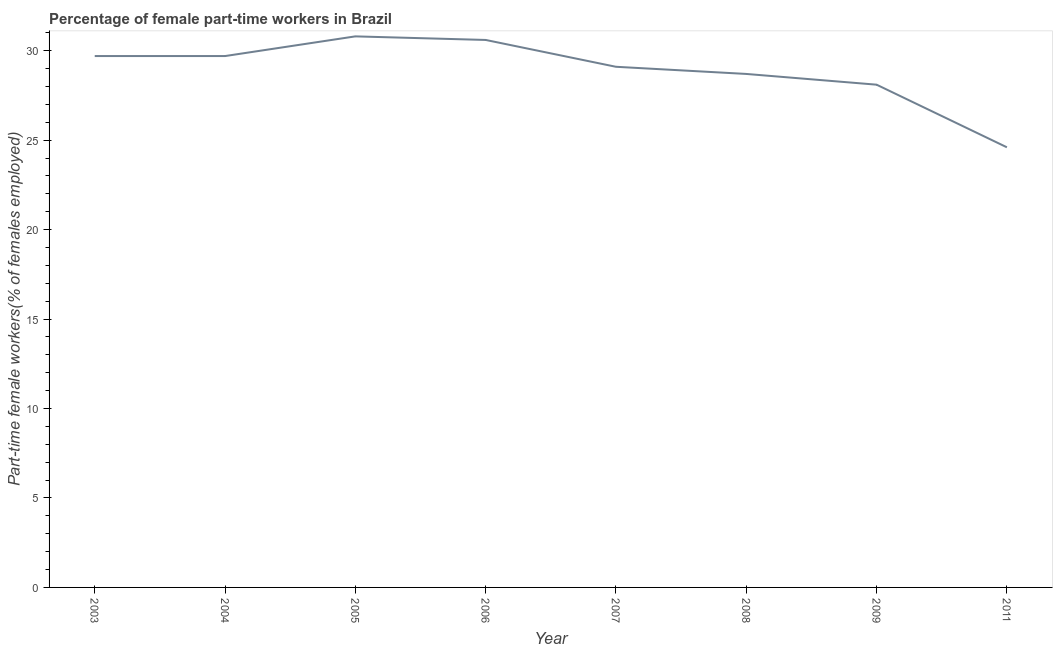What is the percentage of part-time female workers in 2006?
Provide a short and direct response. 30.6. Across all years, what is the maximum percentage of part-time female workers?
Offer a very short reply. 30.8. Across all years, what is the minimum percentage of part-time female workers?
Give a very brief answer. 24.6. In which year was the percentage of part-time female workers maximum?
Give a very brief answer. 2005. In which year was the percentage of part-time female workers minimum?
Offer a very short reply. 2011. What is the sum of the percentage of part-time female workers?
Provide a short and direct response. 231.3. What is the difference between the percentage of part-time female workers in 2004 and 2009?
Keep it short and to the point. 1.6. What is the average percentage of part-time female workers per year?
Offer a terse response. 28.91. What is the median percentage of part-time female workers?
Your answer should be very brief. 29.4. In how many years, is the percentage of part-time female workers greater than 12 %?
Provide a short and direct response. 8. Do a majority of the years between 2007 and 2008 (inclusive) have percentage of part-time female workers greater than 17 %?
Make the answer very short. Yes. What is the ratio of the percentage of part-time female workers in 2004 to that in 2006?
Make the answer very short. 0.97. Is the percentage of part-time female workers in 2003 less than that in 2011?
Your response must be concise. No. What is the difference between the highest and the second highest percentage of part-time female workers?
Make the answer very short. 0.2. What is the difference between the highest and the lowest percentage of part-time female workers?
Provide a succinct answer. 6.2. In how many years, is the percentage of part-time female workers greater than the average percentage of part-time female workers taken over all years?
Make the answer very short. 5. Does the percentage of part-time female workers monotonically increase over the years?
Provide a succinct answer. No. How many years are there in the graph?
Keep it short and to the point. 8. What is the difference between two consecutive major ticks on the Y-axis?
Your answer should be compact. 5. Does the graph contain any zero values?
Offer a terse response. No. Does the graph contain grids?
Keep it short and to the point. No. What is the title of the graph?
Provide a succinct answer. Percentage of female part-time workers in Brazil. What is the label or title of the Y-axis?
Make the answer very short. Part-time female workers(% of females employed). What is the Part-time female workers(% of females employed) of 2003?
Your answer should be very brief. 29.7. What is the Part-time female workers(% of females employed) of 2004?
Provide a succinct answer. 29.7. What is the Part-time female workers(% of females employed) of 2005?
Ensure brevity in your answer.  30.8. What is the Part-time female workers(% of females employed) of 2006?
Your answer should be very brief. 30.6. What is the Part-time female workers(% of females employed) of 2007?
Your answer should be compact. 29.1. What is the Part-time female workers(% of females employed) in 2008?
Your response must be concise. 28.7. What is the Part-time female workers(% of females employed) in 2009?
Your answer should be compact. 28.1. What is the Part-time female workers(% of females employed) in 2011?
Provide a succinct answer. 24.6. What is the difference between the Part-time female workers(% of females employed) in 2003 and 2007?
Give a very brief answer. 0.6. What is the difference between the Part-time female workers(% of females employed) in 2003 and 2008?
Make the answer very short. 1. What is the difference between the Part-time female workers(% of females employed) in 2004 and 2005?
Your answer should be very brief. -1.1. What is the difference between the Part-time female workers(% of females employed) in 2004 and 2008?
Offer a very short reply. 1. What is the difference between the Part-time female workers(% of females employed) in 2004 and 2009?
Provide a succinct answer. 1.6. What is the difference between the Part-time female workers(% of females employed) in 2004 and 2011?
Provide a succinct answer. 5.1. What is the difference between the Part-time female workers(% of females employed) in 2005 and 2008?
Your response must be concise. 2.1. What is the difference between the Part-time female workers(% of females employed) in 2005 and 2009?
Offer a terse response. 2.7. What is the difference between the Part-time female workers(% of females employed) in 2006 and 2007?
Your answer should be compact. 1.5. What is the difference between the Part-time female workers(% of females employed) in 2006 and 2011?
Keep it short and to the point. 6. What is the difference between the Part-time female workers(% of females employed) in 2007 and 2011?
Keep it short and to the point. 4.5. What is the ratio of the Part-time female workers(% of females employed) in 2003 to that in 2008?
Offer a very short reply. 1.03. What is the ratio of the Part-time female workers(% of females employed) in 2003 to that in 2009?
Offer a very short reply. 1.06. What is the ratio of the Part-time female workers(% of females employed) in 2003 to that in 2011?
Keep it short and to the point. 1.21. What is the ratio of the Part-time female workers(% of females employed) in 2004 to that in 2006?
Make the answer very short. 0.97. What is the ratio of the Part-time female workers(% of females employed) in 2004 to that in 2008?
Your response must be concise. 1.03. What is the ratio of the Part-time female workers(% of females employed) in 2004 to that in 2009?
Offer a terse response. 1.06. What is the ratio of the Part-time female workers(% of females employed) in 2004 to that in 2011?
Make the answer very short. 1.21. What is the ratio of the Part-time female workers(% of females employed) in 2005 to that in 2007?
Your answer should be compact. 1.06. What is the ratio of the Part-time female workers(% of females employed) in 2005 to that in 2008?
Your response must be concise. 1.07. What is the ratio of the Part-time female workers(% of females employed) in 2005 to that in 2009?
Keep it short and to the point. 1.1. What is the ratio of the Part-time female workers(% of females employed) in 2005 to that in 2011?
Offer a terse response. 1.25. What is the ratio of the Part-time female workers(% of females employed) in 2006 to that in 2007?
Ensure brevity in your answer.  1.05. What is the ratio of the Part-time female workers(% of females employed) in 2006 to that in 2008?
Make the answer very short. 1.07. What is the ratio of the Part-time female workers(% of females employed) in 2006 to that in 2009?
Provide a short and direct response. 1.09. What is the ratio of the Part-time female workers(% of females employed) in 2006 to that in 2011?
Provide a succinct answer. 1.24. What is the ratio of the Part-time female workers(% of females employed) in 2007 to that in 2009?
Your answer should be compact. 1.04. What is the ratio of the Part-time female workers(% of females employed) in 2007 to that in 2011?
Make the answer very short. 1.18. What is the ratio of the Part-time female workers(% of females employed) in 2008 to that in 2009?
Give a very brief answer. 1.02. What is the ratio of the Part-time female workers(% of females employed) in 2008 to that in 2011?
Keep it short and to the point. 1.17. What is the ratio of the Part-time female workers(% of females employed) in 2009 to that in 2011?
Your answer should be very brief. 1.14. 